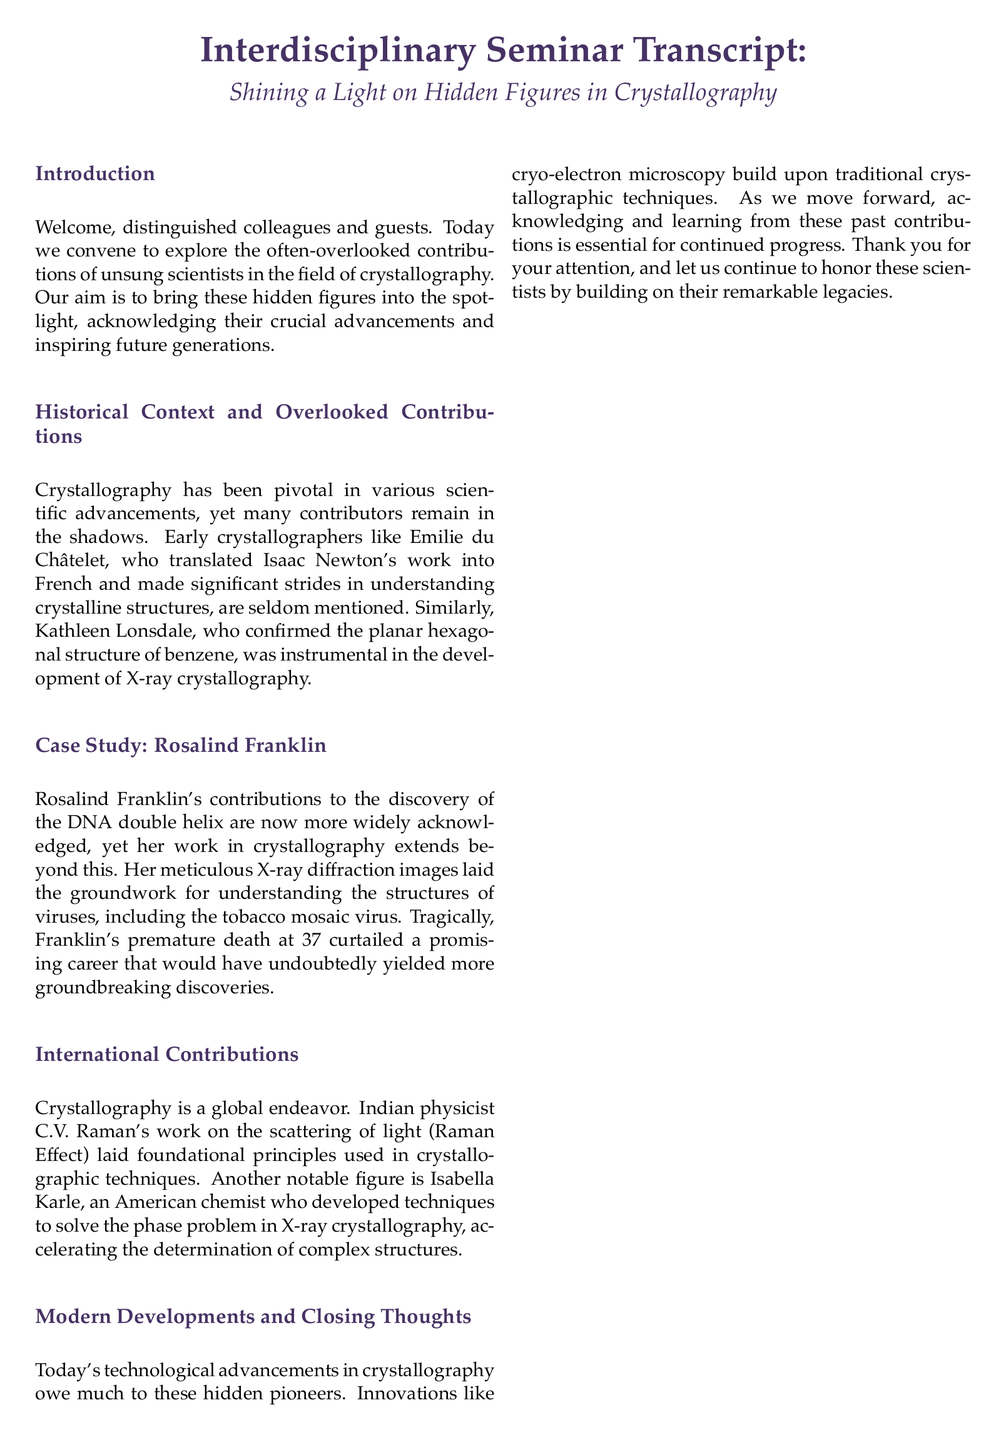What is the title of the seminar? The title is the main focus of the seminar, highlighting its theme for attendees.
Answer: Shining a Light on Hidden Figures in Crystallography Who is mentioned as instrumental in the development of X-ray crystallography? This person played a significant role in understanding crystalline structures and is highlighted in the document.
Answer: Kathleen Lonsdale At what age did Rosalind Franklin pass away? The document mentions the age at which Rosalind Franklin died, emphasizing the tragedy of her early death.
Answer: 37 Which physicist's work is associated with the Raman Effect? The document highlights the contributions of this physicist to the foundational principles used in crystallographic techniques.
Answer: C.V. Raman What is a modern advancement mentioned that builds upon traditional crystallographic techniques? This technological innovation is seen as a contemporary development in the field of crystallography.
Answer: cryo-electron microscopy Which scientist translated Isaac Newton's work into French? This person's efforts are notable in the historical context of crystallography contributions mentioned in the seminar.
Answer: Emilie du Châtelet What does the conclusion emphasize about scientific progress? The conclusion highlights a key idea related to the importance of collective contributions in science.
Answer: collective endeavor What type of seminar is being discussed in the document? This term encapsulates the purpose and format of the gathering detailed in the transcript.
Answer: interdisciplinary seminar 